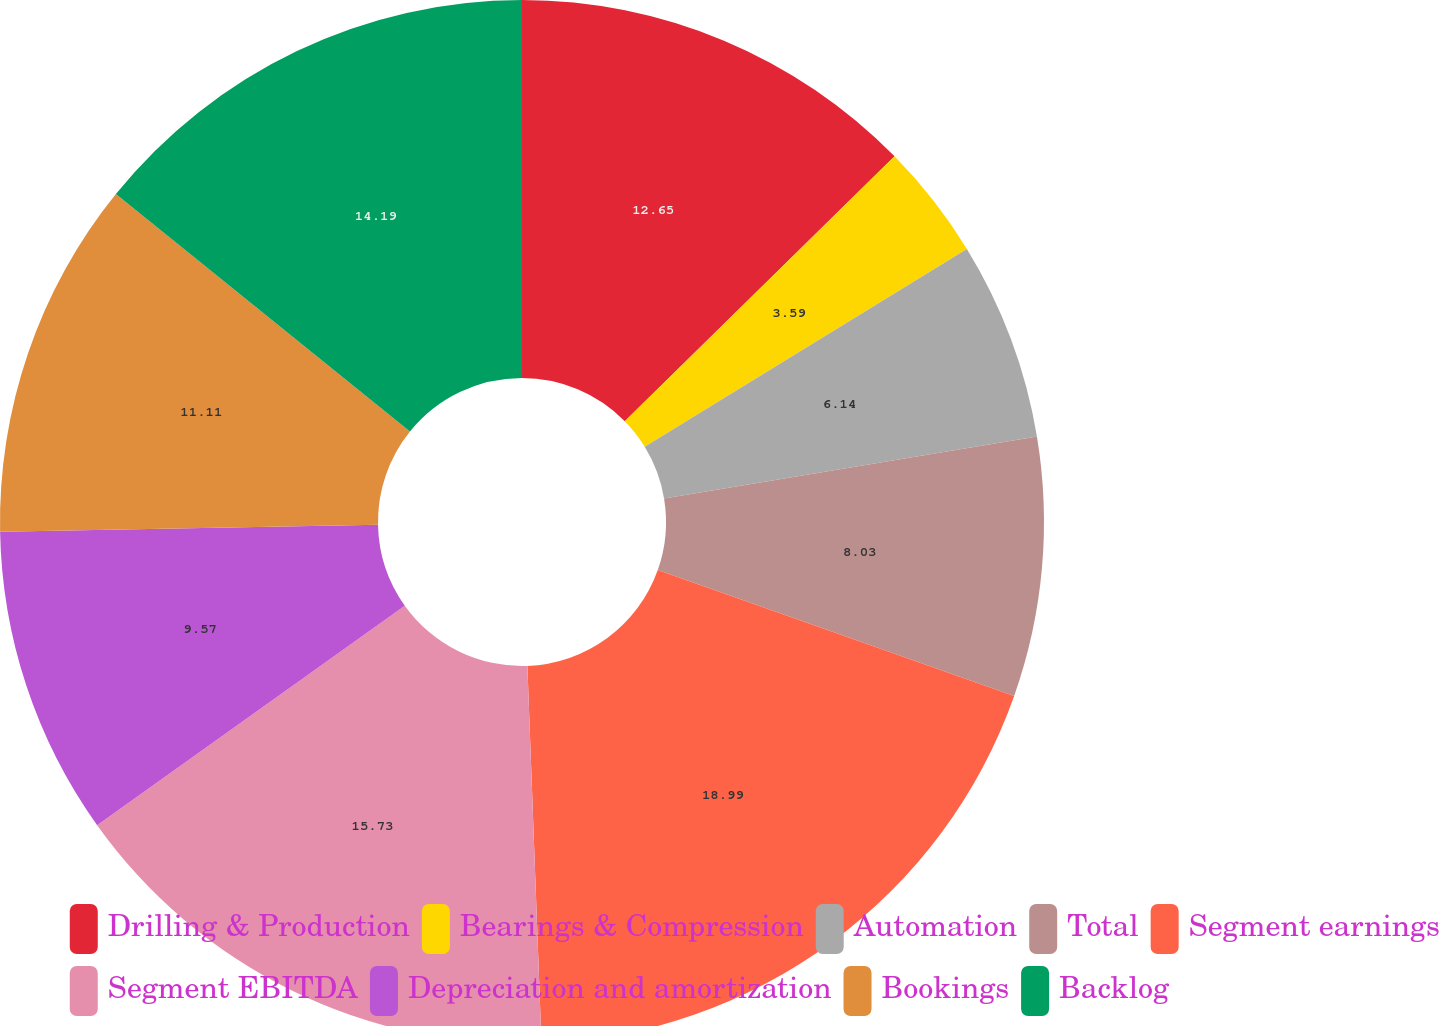Convert chart to OTSL. <chart><loc_0><loc_0><loc_500><loc_500><pie_chart><fcel>Drilling & Production<fcel>Bearings & Compression<fcel>Automation<fcel>Total<fcel>Segment earnings<fcel>Segment EBITDA<fcel>Depreciation and amortization<fcel>Bookings<fcel>Backlog<nl><fcel>12.65%<fcel>3.59%<fcel>6.14%<fcel>8.03%<fcel>19.0%<fcel>15.73%<fcel>9.57%<fcel>11.11%<fcel>14.19%<nl></chart> 